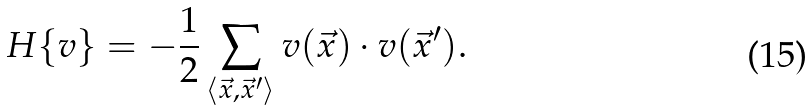Convert formula to latex. <formula><loc_0><loc_0><loc_500><loc_500>H \{ v \} = - { \frac { 1 } { 2 } } \sum _ { \langle \vec { x } , { \vec { x } } ^ { \prime } \rangle } v ( \vec { x } ) \cdot v ( { \vec { x } } ^ { \prime } ) .</formula> 